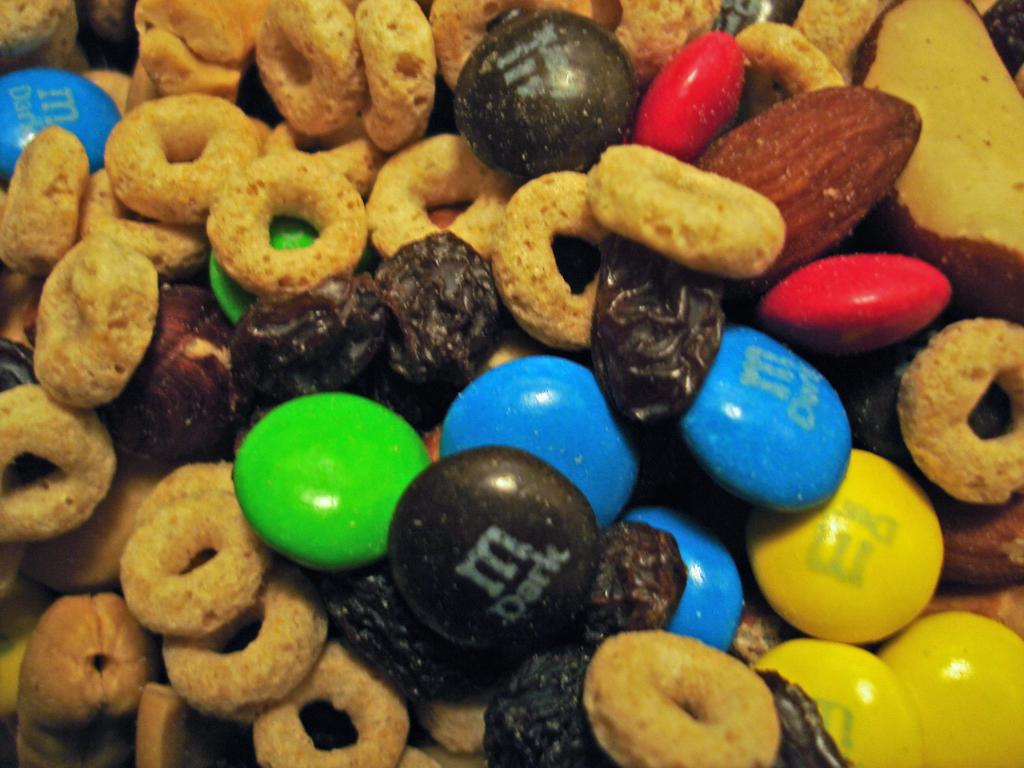What type of valuable items are present in the image? There are gems in the image. What type of fruit is visible in the image? There is an apple in the image. Besides the gems and apple, what other items can be seen in the image? There are other food items in the image. What type of band is playing music in the image? There is no band present in the image. How many dimes are visible on the table in the image? There is no mention of dimes in the image; it features gems, an apple, and other food items. Is there a camping site visible in the image? There is no camping site present in the image. 